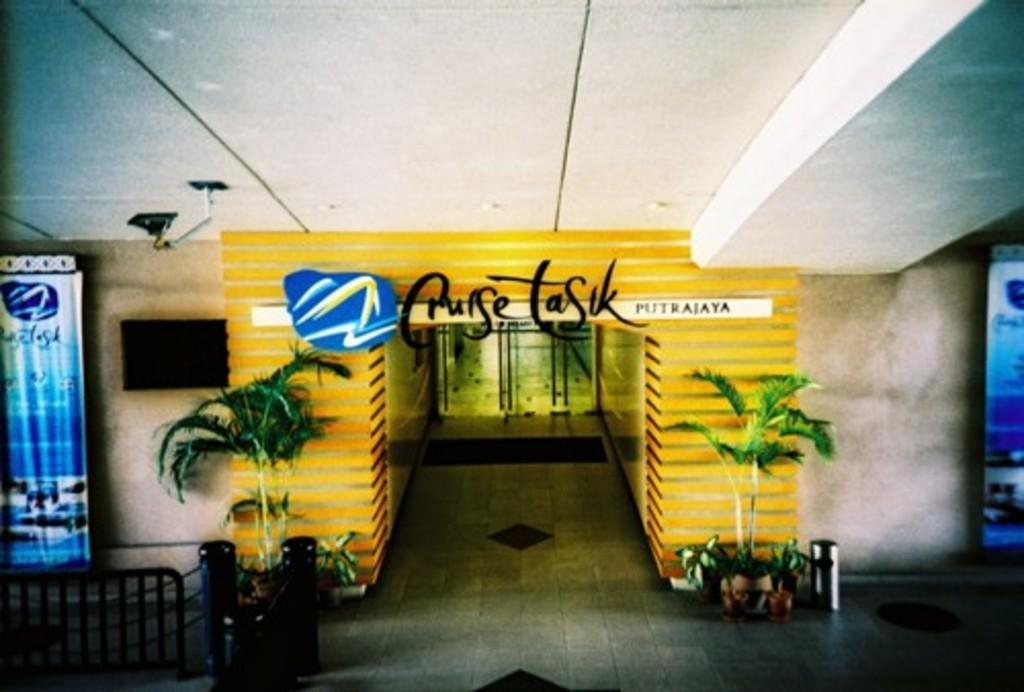<image>
Write a terse but informative summary of the picture. A Cruise Task store with palm trees outside of it . 